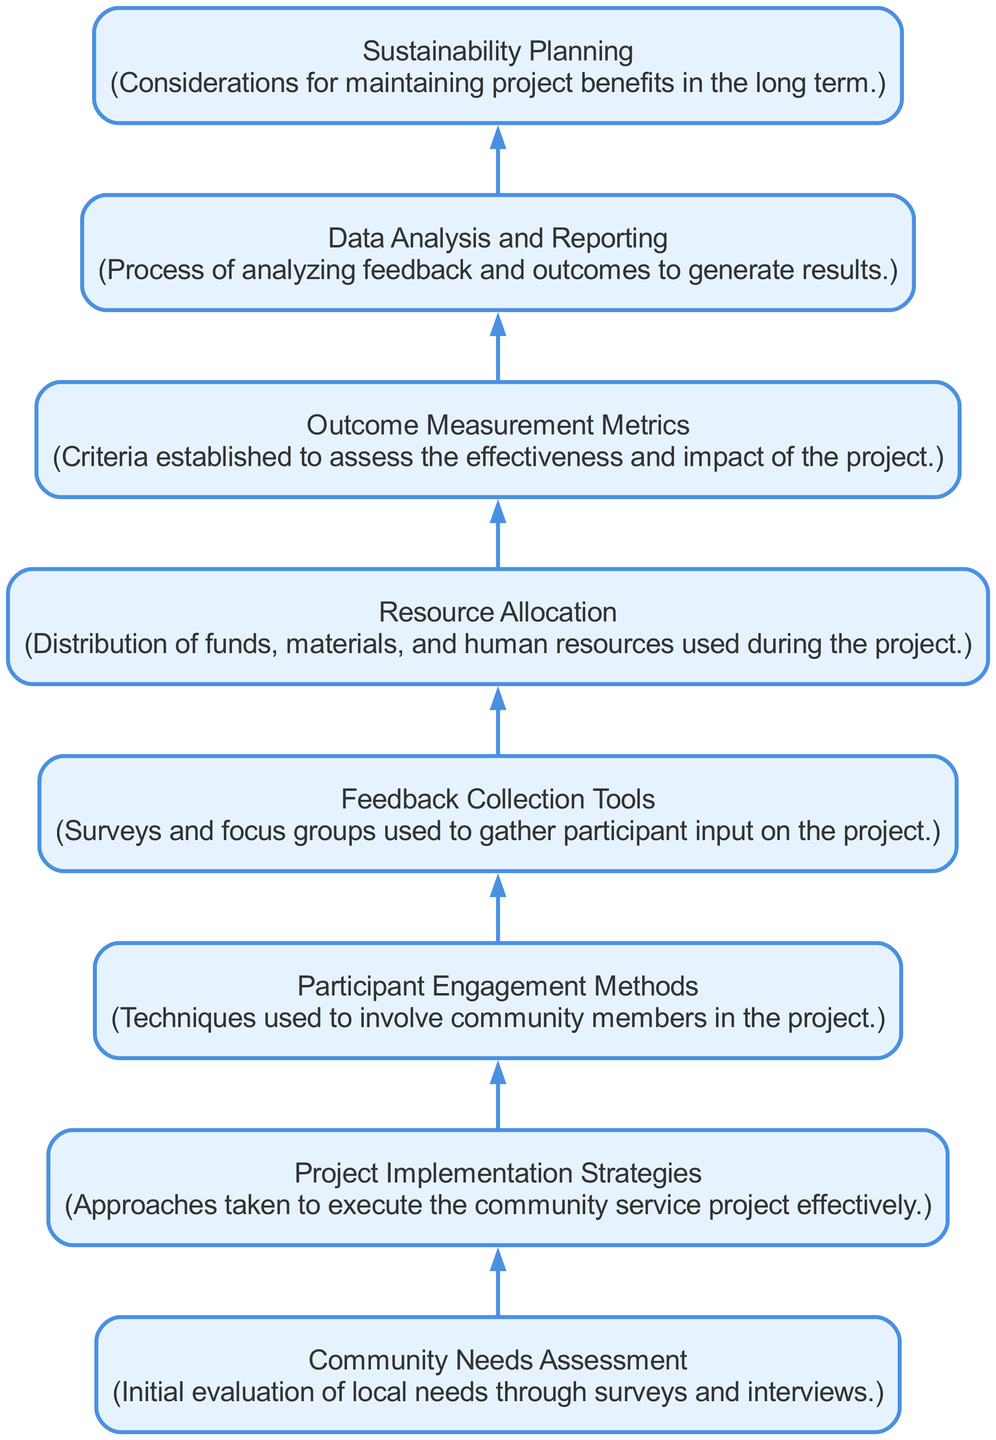What is the first step in the flow chart? The first step illustrated in the flow chart is "Community Needs Assessment," indicating the initial evaluation of local needs.
Answer: Community Needs Assessment How many nodes are present in the diagram? The diagram features eight distinct nodes, each representing a component of the community service project assessment process.
Answer: Eight What node follows "Resource Allocation"? The node that directly follows "Resource Allocation" is "Outcome Measurement Metrics," showing the next stage in the project evaluation process.
Answer: Outcome Measurement Metrics Which node is connected to "Feedback Collection Tools"? Connected to "Feedback Collection Tools" is "Resource Allocation," indicating that resource distribution happens after collecting participant feedback.
Answer: Resource Allocation What is the final outcome assessed in the diagram? The last outcome assessed in the diagram is "Sustainability Planning," which considers the long-term maintenance of project benefits.
Answer: Sustainability Planning What is the relationship between "Project Implementation Strategies" and "Participant Engagement Methods"? "Project Implementation Strategies" leads to "Participant Engagement Methods," showing that strategies for implementation inform how participants will be engaged.
Answer: Leads to What is the purpose of "Data Analysis and Reporting"? The purpose of "Data Analysis and Reporting" is to analyze feedback and project outcomes to generate results for the community service project assessment.
Answer: Analyze feedback and outcomes How does participant feedback influence resource allocation? Participant feedback, gathered through "Feedback Collection Tools," informs the "Resource Allocation" step, meaning that input received helps determine how resources are distributed.
Answer: Informs distribution 